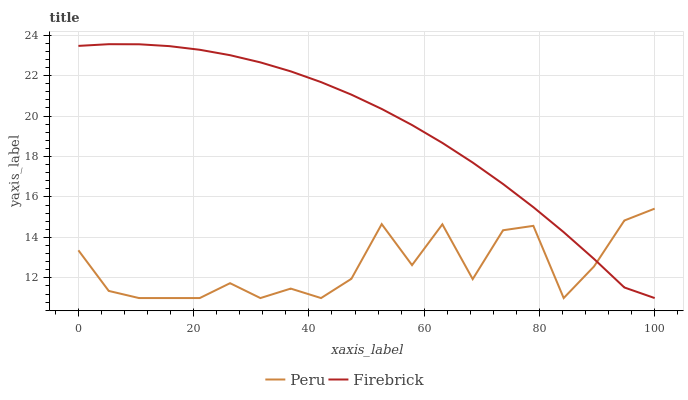Does Peru have the maximum area under the curve?
Answer yes or no. No. Is Peru the smoothest?
Answer yes or no. No. Does Peru have the highest value?
Answer yes or no. No. 